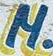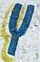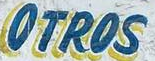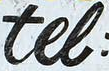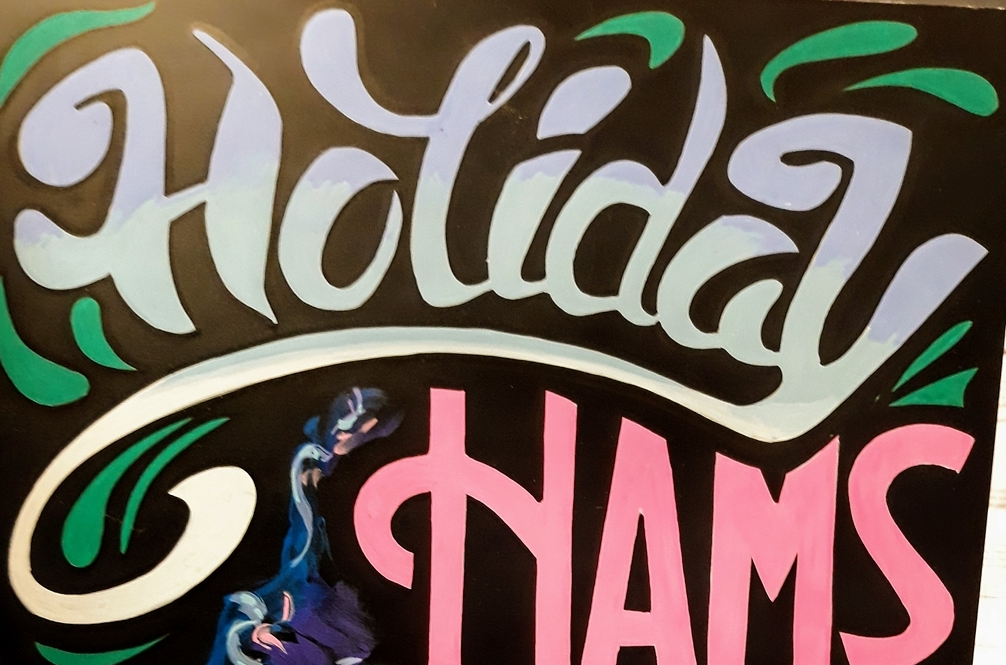Identify the words shown in these images in order, separated by a semicolon. M; Y; OTROS; tel; Holiday 